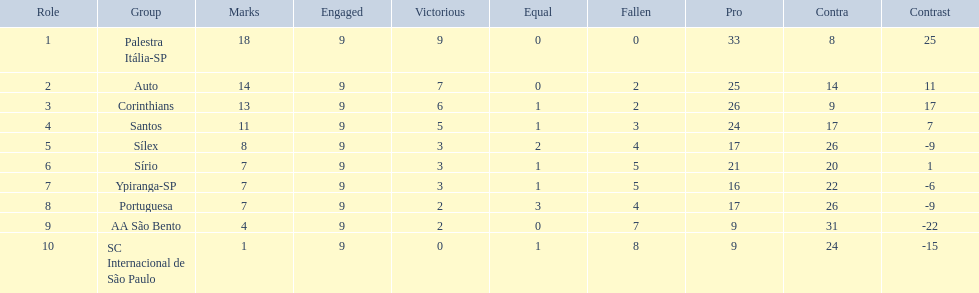How many games did each team play? 9, 9, 9, 9, 9, 9, 9, 9, 9, 9. Did any team score 13 points in the total games they played? 13. What is the name of that team? Corinthians. 